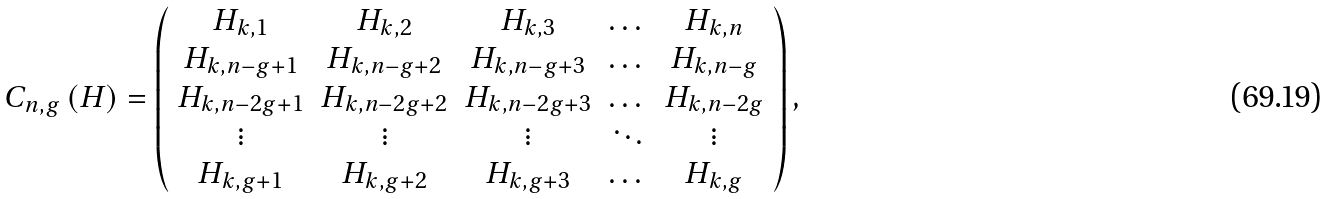<formula> <loc_0><loc_0><loc_500><loc_500>C _ { n , g } \left ( H \right ) = \left ( \begin{array} { c c c c c } H _ { k , 1 } & H _ { k , 2 } & H _ { k , 3 } & \dots & H _ { k , n } \\ H _ { k , n - g + 1 } & H _ { k , n - g + 2 } & H _ { k , n - g + 3 } & \dots & H _ { k , n - g } \\ H _ { k , n - 2 g + 1 } & H _ { k , n - 2 g + 2 } & H _ { k , n - 2 g + 3 } & \dots & H _ { k , n - 2 g } \\ \vdots & \vdots & \vdots & \ddots & \vdots \\ H _ { k , g + 1 } & H _ { k , g + 2 } & H _ { k , g + 3 } & \dots & H _ { k , g } \end{array} \right ) ,</formula> 